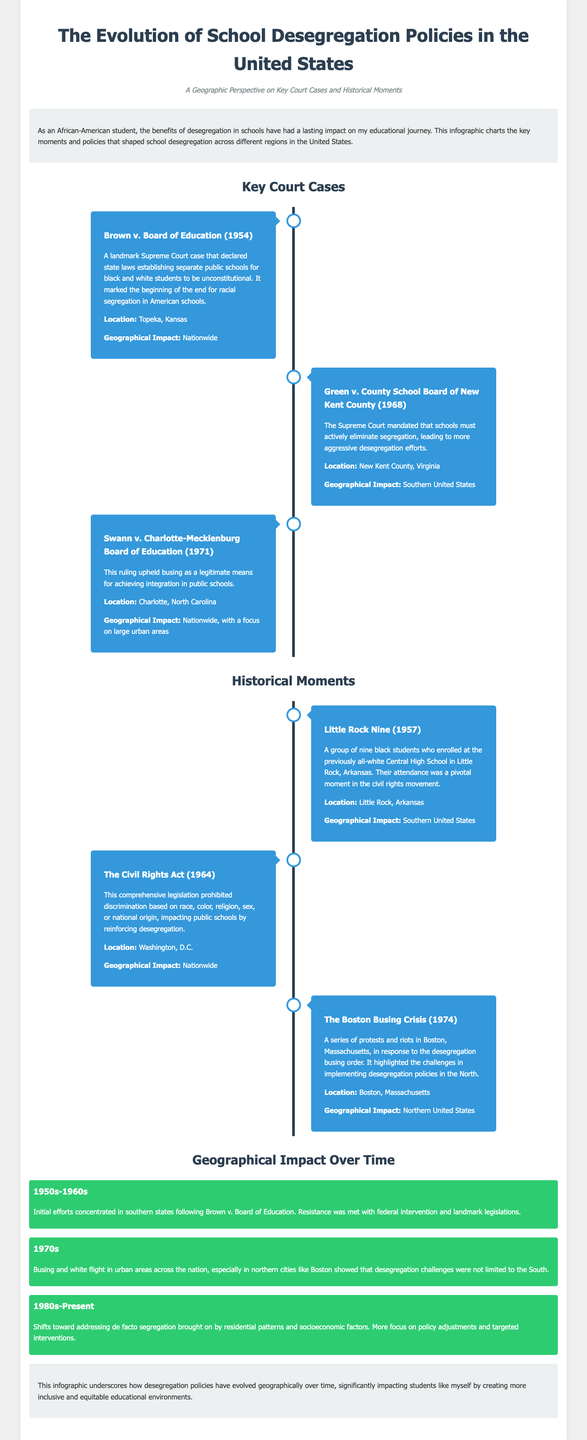What was the landmark case that declared separate schools unconstitutional? The document states that Brown v. Board of Education was the case that declared state laws establishing separate public schools for black and white students unconstitutional.
Answer: Brown v. Board of Education In what year did the Little Rock Nine attend Central High School? The document mentions the Little Rock Nine enrolled in 1957, marking a pivotal moment in the civil rights movement.
Answer: 1957 Which court case mandated schools must actively eliminate segregation? According to the document, Green v. County School Board of New Kent County mandated that schools must actively eliminate segregation.
Answer: Green v. County School Board of New Kent County What geographical area did the Boston Busing Crisis primarily affect? The document clarifies that the Boston Busing Crisis affected Boston, Massachusetts, and was significant in highlighting implementation challenges.
Answer: Boston, Massachusetts What legislation prohibited discrimination in public schools? The Civil Rights Act of 1964 is identified in the document as the legislation that prohibited discrimination based on race, color, religion, sex, or national origin.
Answer: The Civil Rights Act (1964) During which decades were initial desegregation efforts concentrated in southern states? The document states that the 1950s and 1960s were the decades when initial efforts concentrated on southern states.
Answer: 1950s-1960s What policy was upheld by the Swann v. Charlotte-Mecklenburg Board of Education case? According to the document, the case upheld busing as a legitimate means for achieving integration in public schools.
Answer: Busing What event represented a major challenge to desegregation in Northern cities? The document indicates that the Boston Busing Crisis highlighted significant challenges to desegregation policies in Northern cities.
Answer: Boston Busing Crisis 